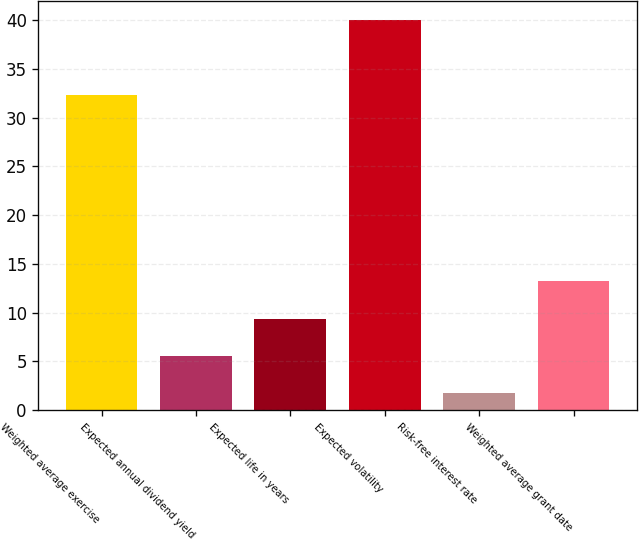Convert chart to OTSL. <chart><loc_0><loc_0><loc_500><loc_500><bar_chart><fcel>Weighted average exercise<fcel>Expected annual dividend yield<fcel>Expected life in years<fcel>Expected volatility<fcel>Risk-free interest rate<fcel>Weighted average grant date<nl><fcel>32.3<fcel>5.53<fcel>9.36<fcel>40<fcel>1.7<fcel>13.19<nl></chart> 